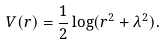<formula> <loc_0><loc_0><loc_500><loc_500>V ( r ) = \frac { 1 } { 2 } \log ( r ^ { 2 } + \lambda ^ { 2 } ) .</formula> 